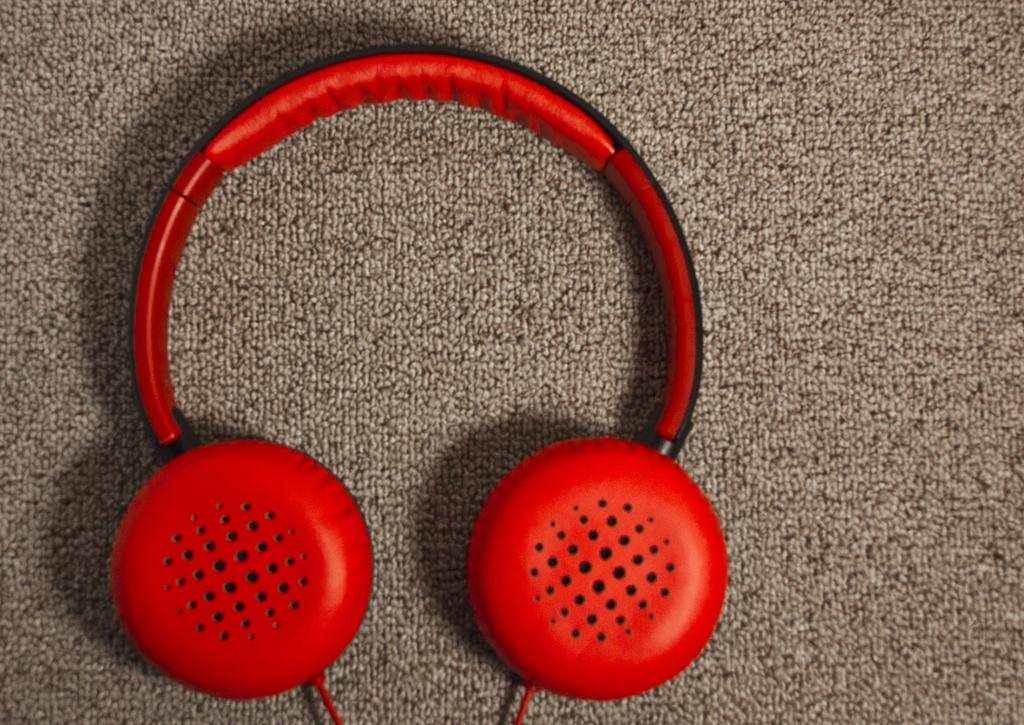What is the main object in the center of the image? There is a headset in the image, and it is placed on a cloth. What is the headset placed on? The headset is placed on a cloth. Where is the headset and cloth located in the image? The headset and cloth are in the center of the image. What type of jeans is the writer wearing in the image? There is no writer or jeans present in the image; it only features a headset placed on a cloth. 